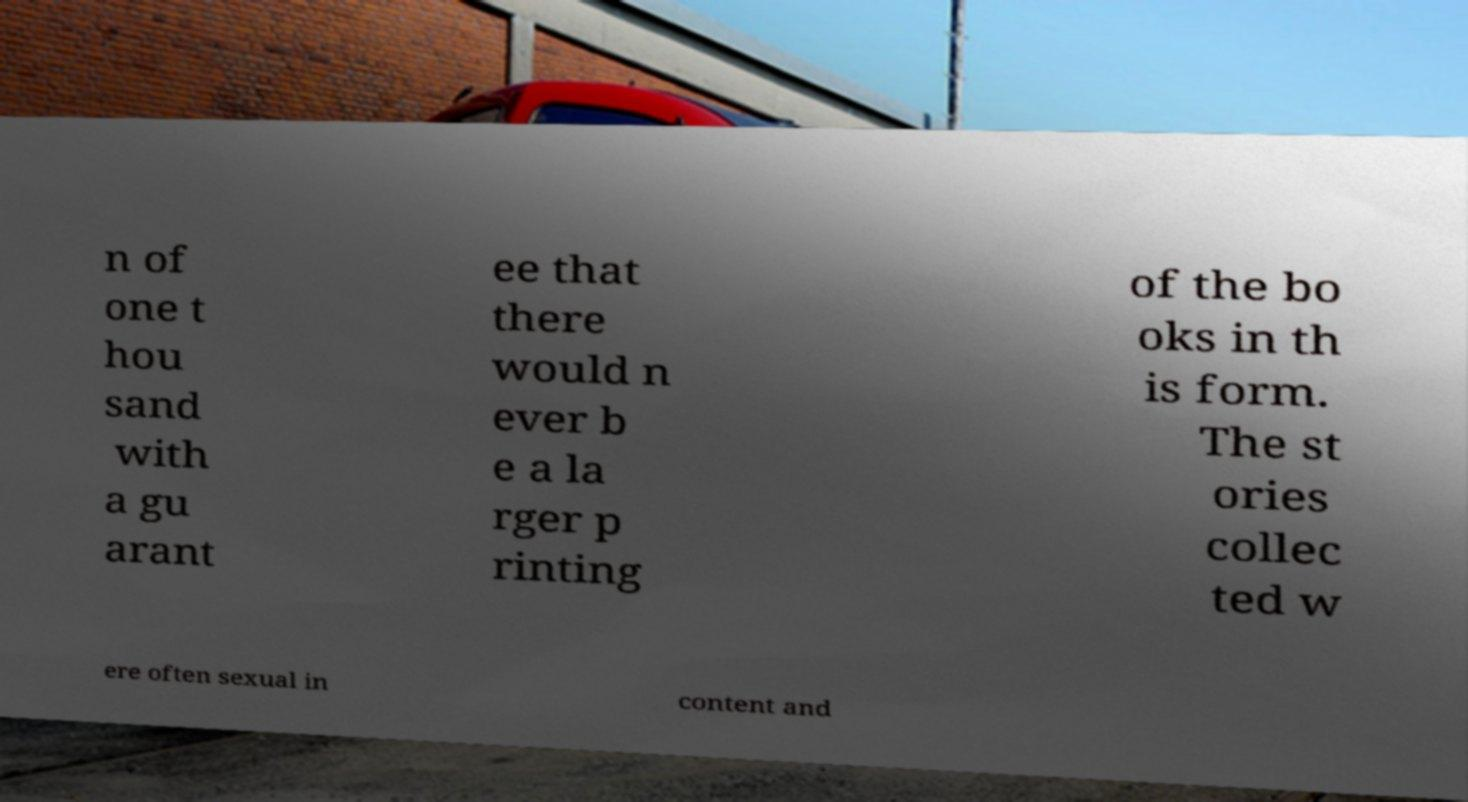Please read and relay the text visible in this image. What does it say? n of one t hou sand with a gu arant ee that there would n ever b e a la rger p rinting of the bo oks in th is form. The st ories collec ted w ere often sexual in content and 